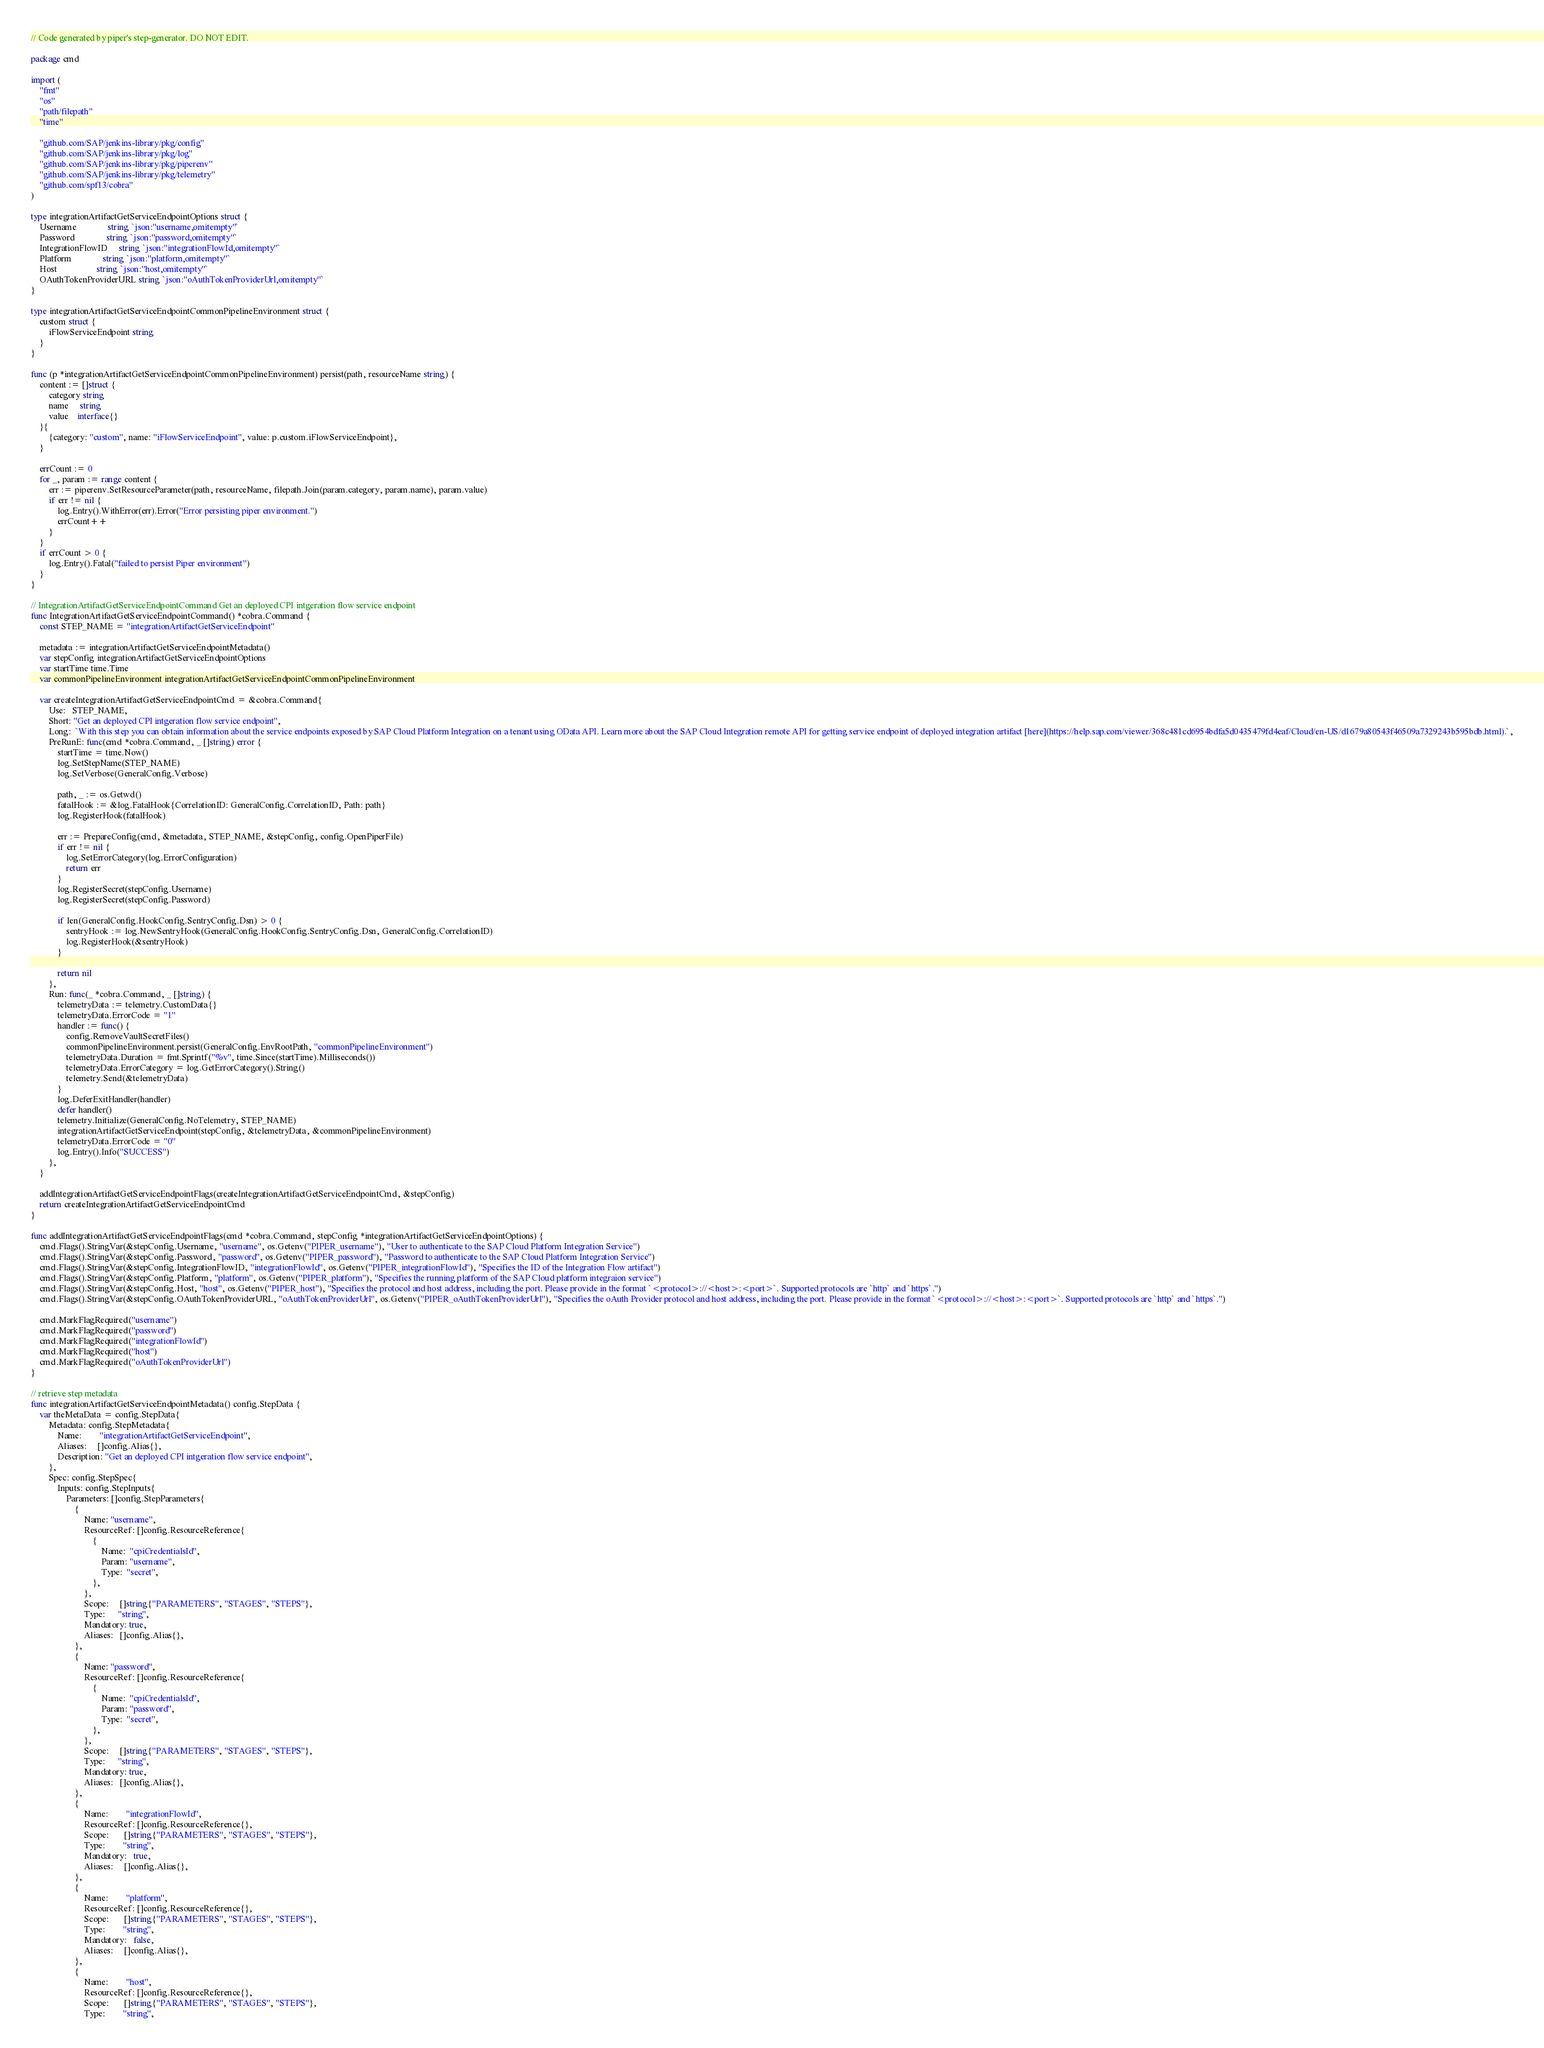<code> <loc_0><loc_0><loc_500><loc_500><_Go_>// Code generated by piper's step-generator. DO NOT EDIT.

package cmd

import (
	"fmt"
	"os"
	"path/filepath"
	"time"

	"github.com/SAP/jenkins-library/pkg/config"
	"github.com/SAP/jenkins-library/pkg/log"
	"github.com/SAP/jenkins-library/pkg/piperenv"
	"github.com/SAP/jenkins-library/pkg/telemetry"
	"github.com/spf13/cobra"
)

type integrationArtifactGetServiceEndpointOptions struct {
	Username              string `json:"username,omitempty"`
	Password              string `json:"password,omitempty"`
	IntegrationFlowID     string `json:"integrationFlowId,omitempty"`
	Platform              string `json:"platform,omitempty"`
	Host                  string `json:"host,omitempty"`
	OAuthTokenProviderURL string `json:"oAuthTokenProviderUrl,omitempty"`
}

type integrationArtifactGetServiceEndpointCommonPipelineEnvironment struct {
	custom struct {
		iFlowServiceEndpoint string
	}
}

func (p *integrationArtifactGetServiceEndpointCommonPipelineEnvironment) persist(path, resourceName string) {
	content := []struct {
		category string
		name     string
		value    interface{}
	}{
		{category: "custom", name: "iFlowServiceEndpoint", value: p.custom.iFlowServiceEndpoint},
	}

	errCount := 0
	for _, param := range content {
		err := piperenv.SetResourceParameter(path, resourceName, filepath.Join(param.category, param.name), param.value)
		if err != nil {
			log.Entry().WithError(err).Error("Error persisting piper environment.")
			errCount++
		}
	}
	if errCount > 0 {
		log.Entry().Fatal("failed to persist Piper environment")
	}
}

// IntegrationArtifactGetServiceEndpointCommand Get an deployed CPI intgeration flow service endpoint
func IntegrationArtifactGetServiceEndpointCommand() *cobra.Command {
	const STEP_NAME = "integrationArtifactGetServiceEndpoint"

	metadata := integrationArtifactGetServiceEndpointMetadata()
	var stepConfig integrationArtifactGetServiceEndpointOptions
	var startTime time.Time
	var commonPipelineEnvironment integrationArtifactGetServiceEndpointCommonPipelineEnvironment

	var createIntegrationArtifactGetServiceEndpointCmd = &cobra.Command{
		Use:   STEP_NAME,
		Short: "Get an deployed CPI intgeration flow service endpoint",
		Long:  `With this step you can obtain information about the service endpoints exposed by SAP Cloud Platform Integration on a tenant using OData API. Learn more about the SAP Cloud Integration remote API for getting service endpoint of deployed integration artifact [here](https://help.sap.com/viewer/368c481cd6954bdfa5d0435479fd4eaf/Cloud/en-US/d1679a80543f46509a7329243b595bdb.html).`,
		PreRunE: func(cmd *cobra.Command, _ []string) error {
			startTime = time.Now()
			log.SetStepName(STEP_NAME)
			log.SetVerbose(GeneralConfig.Verbose)

			path, _ := os.Getwd()
			fatalHook := &log.FatalHook{CorrelationID: GeneralConfig.CorrelationID, Path: path}
			log.RegisterHook(fatalHook)

			err := PrepareConfig(cmd, &metadata, STEP_NAME, &stepConfig, config.OpenPiperFile)
			if err != nil {
				log.SetErrorCategory(log.ErrorConfiguration)
				return err
			}
			log.RegisterSecret(stepConfig.Username)
			log.RegisterSecret(stepConfig.Password)

			if len(GeneralConfig.HookConfig.SentryConfig.Dsn) > 0 {
				sentryHook := log.NewSentryHook(GeneralConfig.HookConfig.SentryConfig.Dsn, GeneralConfig.CorrelationID)
				log.RegisterHook(&sentryHook)
			}

			return nil
		},
		Run: func(_ *cobra.Command, _ []string) {
			telemetryData := telemetry.CustomData{}
			telemetryData.ErrorCode = "1"
			handler := func() {
				config.RemoveVaultSecretFiles()
				commonPipelineEnvironment.persist(GeneralConfig.EnvRootPath, "commonPipelineEnvironment")
				telemetryData.Duration = fmt.Sprintf("%v", time.Since(startTime).Milliseconds())
				telemetryData.ErrorCategory = log.GetErrorCategory().String()
				telemetry.Send(&telemetryData)
			}
			log.DeferExitHandler(handler)
			defer handler()
			telemetry.Initialize(GeneralConfig.NoTelemetry, STEP_NAME)
			integrationArtifactGetServiceEndpoint(stepConfig, &telemetryData, &commonPipelineEnvironment)
			telemetryData.ErrorCode = "0"
			log.Entry().Info("SUCCESS")
		},
	}

	addIntegrationArtifactGetServiceEndpointFlags(createIntegrationArtifactGetServiceEndpointCmd, &stepConfig)
	return createIntegrationArtifactGetServiceEndpointCmd
}

func addIntegrationArtifactGetServiceEndpointFlags(cmd *cobra.Command, stepConfig *integrationArtifactGetServiceEndpointOptions) {
	cmd.Flags().StringVar(&stepConfig.Username, "username", os.Getenv("PIPER_username"), "User to authenticate to the SAP Cloud Platform Integration Service")
	cmd.Flags().StringVar(&stepConfig.Password, "password", os.Getenv("PIPER_password"), "Password to authenticate to the SAP Cloud Platform Integration Service")
	cmd.Flags().StringVar(&stepConfig.IntegrationFlowID, "integrationFlowId", os.Getenv("PIPER_integrationFlowId"), "Specifies the ID of the Integration Flow artifact")
	cmd.Flags().StringVar(&stepConfig.Platform, "platform", os.Getenv("PIPER_platform"), "Specifies the running platform of the SAP Cloud platform integraion service")
	cmd.Flags().StringVar(&stepConfig.Host, "host", os.Getenv("PIPER_host"), "Specifies the protocol and host address, including the port. Please provide in the format `<protocol>://<host>:<port>`. Supported protocols are `http` and `https`.")
	cmd.Flags().StringVar(&stepConfig.OAuthTokenProviderURL, "oAuthTokenProviderUrl", os.Getenv("PIPER_oAuthTokenProviderUrl"), "Specifies the oAuth Provider protocol and host address, including the port. Please provide in the format `<protocol>://<host>:<port>`. Supported protocols are `http` and `https`.")

	cmd.MarkFlagRequired("username")
	cmd.MarkFlagRequired("password")
	cmd.MarkFlagRequired("integrationFlowId")
	cmd.MarkFlagRequired("host")
	cmd.MarkFlagRequired("oAuthTokenProviderUrl")
}

// retrieve step metadata
func integrationArtifactGetServiceEndpointMetadata() config.StepData {
	var theMetaData = config.StepData{
		Metadata: config.StepMetadata{
			Name:        "integrationArtifactGetServiceEndpoint",
			Aliases:     []config.Alias{},
			Description: "Get an deployed CPI intgeration flow service endpoint",
		},
		Spec: config.StepSpec{
			Inputs: config.StepInputs{
				Parameters: []config.StepParameters{
					{
						Name: "username",
						ResourceRef: []config.ResourceReference{
							{
								Name:  "cpiCredentialsId",
								Param: "username",
								Type:  "secret",
							},
						},
						Scope:     []string{"PARAMETERS", "STAGES", "STEPS"},
						Type:      "string",
						Mandatory: true,
						Aliases:   []config.Alias{},
					},
					{
						Name: "password",
						ResourceRef: []config.ResourceReference{
							{
								Name:  "cpiCredentialsId",
								Param: "password",
								Type:  "secret",
							},
						},
						Scope:     []string{"PARAMETERS", "STAGES", "STEPS"},
						Type:      "string",
						Mandatory: true,
						Aliases:   []config.Alias{},
					},
					{
						Name:        "integrationFlowId",
						ResourceRef: []config.ResourceReference{},
						Scope:       []string{"PARAMETERS", "STAGES", "STEPS"},
						Type:        "string",
						Mandatory:   true,
						Aliases:     []config.Alias{},
					},
					{
						Name:        "platform",
						ResourceRef: []config.ResourceReference{},
						Scope:       []string{"PARAMETERS", "STAGES", "STEPS"},
						Type:        "string",
						Mandatory:   false,
						Aliases:     []config.Alias{},
					},
					{
						Name:        "host",
						ResourceRef: []config.ResourceReference{},
						Scope:       []string{"PARAMETERS", "STAGES", "STEPS"},
						Type:        "string",</code> 